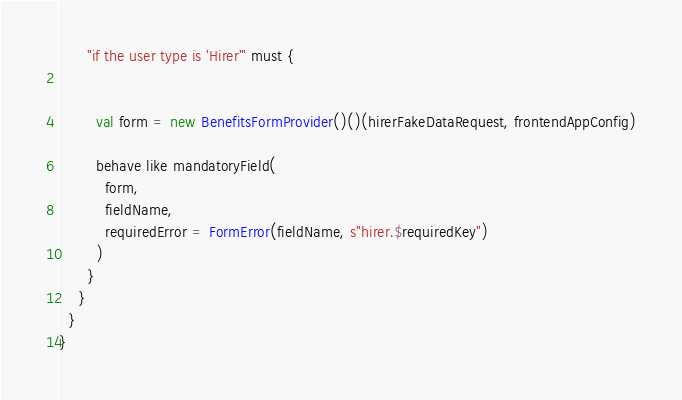Convert code to text. <code><loc_0><loc_0><loc_500><loc_500><_Scala_>      "if the user type is 'Hirer'" must {


        val form = new BenefitsFormProvider()()(hirerFakeDataRequest, frontendAppConfig)

        behave like mandatoryField(
          form,
          fieldName,
          requiredError = FormError(fieldName, s"hirer.$requiredKey")
        )
      }
    }
  }
}
</code> 